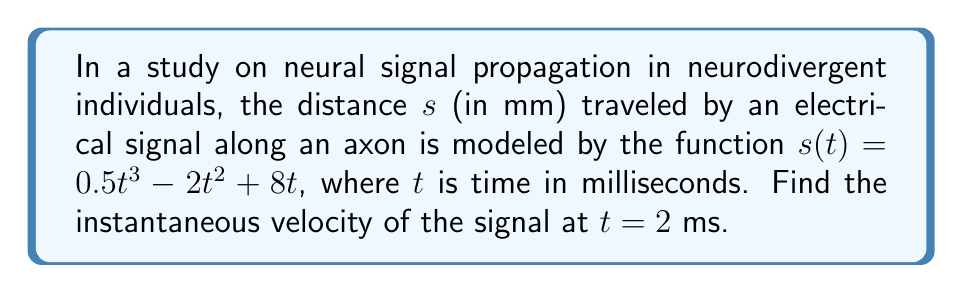Solve this math problem. To find the instantaneous velocity, we need to calculate the derivative of the position function $s(t)$ and evaluate it at $t = 2$ ms.

Step 1: Find the derivative of $s(t)$.
$$\frac{d}{dt}s(t) = \frac{d}{dt}(0.5t^3 - 2t^2 + 8t)$$
$$v(t) = 1.5t^2 - 4t + 8$$

Step 2: Evaluate the derivative at $t = 2$ ms.
$$v(2) = 1.5(2)^2 - 4(2) + 8$$
$$v(2) = 1.5(4) - 8 + 8$$
$$v(2) = 6 - 8 + 8$$
$$v(2) = 6$$

The instantaneous velocity at $t = 2$ ms is 6 mm/ms.
Answer: 6 mm/ms 